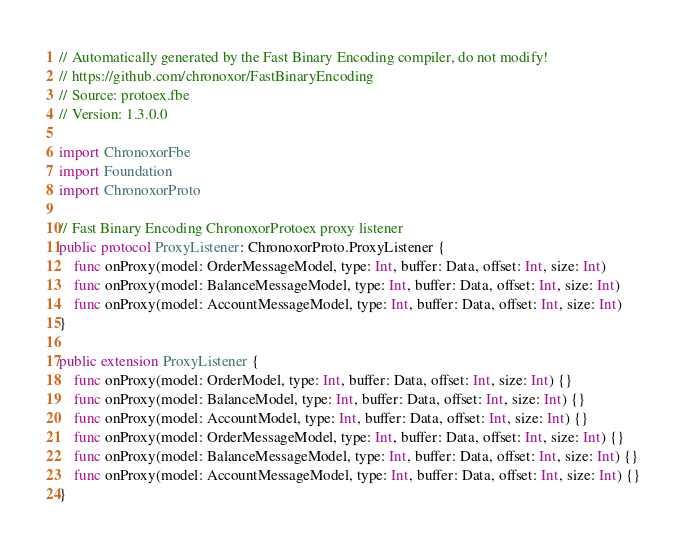Convert code to text. <code><loc_0><loc_0><loc_500><loc_500><_Swift_>// Automatically generated by the Fast Binary Encoding compiler, do not modify!
// https://github.com/chronoxor/FastBinaryEncoding
// Source: protoex.fbe
// Version: 1.3.0.0

import ChronoxorFbe
import Foundation
import ChronoxorProto

// Fast Binary Encoding ChronoxorProtoex proxy listener
public protocol ProxyListener: ChronoxorProto.ProxyListener {
    func onProxy(model: OrderMessageModel, type: Int, buffer: Data, offset: Int, size: Int)
    func onProxy(model: BalanceMessageModel, type: Int, buffer: Data, offset: Int, size: Int)
    func onProxy(model: AccountMessageModel, type: Int, buffer: Data, offset: Int, size: Int)
}

public extension ProxyListener {
    func onProxy(model: OrderModel, type: Int, buffer: Data, offset: Int, size: Int) {}
    func onProxy(model: BalanceModel, type: Int, buffer: Data, offset: Int, size: Int) {}
    func onProxy(model: AccountModel, type: Int, buffer: Data, offset: Int, size: Int) {}
    func onProxy(model: OrderMessageModel, type: Int, buffer: Data, offset: Int, size: Int) {}
    func onProxy(model: BalanceMessageModel, type: Int, buffer: Data, offset: Int, size: Int) {}
    func onProxy(model: AccountMessageModel, type: Int, buffer: Data, offset: Int, size: Int) {}
}
</code> 